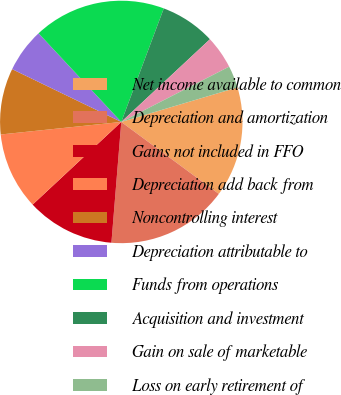Convert chart. <chart><loc_0><loc_0><loc_500><loc_500><pie_chart><fcel>Net income available to common<fcel>Depreciation and amortization<fcel>Gains not included in FFO<fcel>Depreciation add back from<fcel>Noncontrolling interest<fcel>Depreciation attributable to<fcel>Funds from operations<fcel>Acquisition and investment<fcel>Gain on sale of marketable<fcel>Loss on early retirement of<nl><fcel>14.71%<fcel>16.18%<fcel>11.76%<fcel>10.29%<fcel>8.82%<fcel>5.88%<fcel>17.65%<fcel>7.35%<fcel>4.41%<fcel>2.94%<nl></chart> 